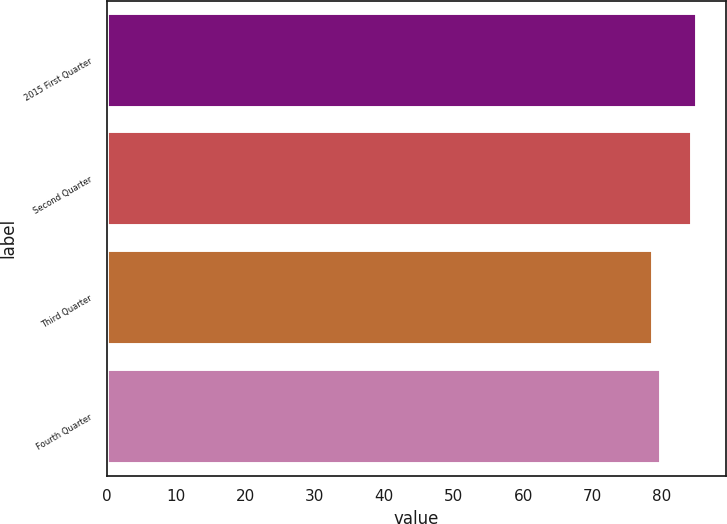<chart> <loc_0><loc_0><loc_500><loc_500><bar_chart><fcel>2015 First Quarter<fcel>Second Quarter<fcel>Third Quarter<fcel>Fourth Quarter<nl><fcel>85<fcel>84.33<fcel>78.76<fcel>79.88<nl></chart> 